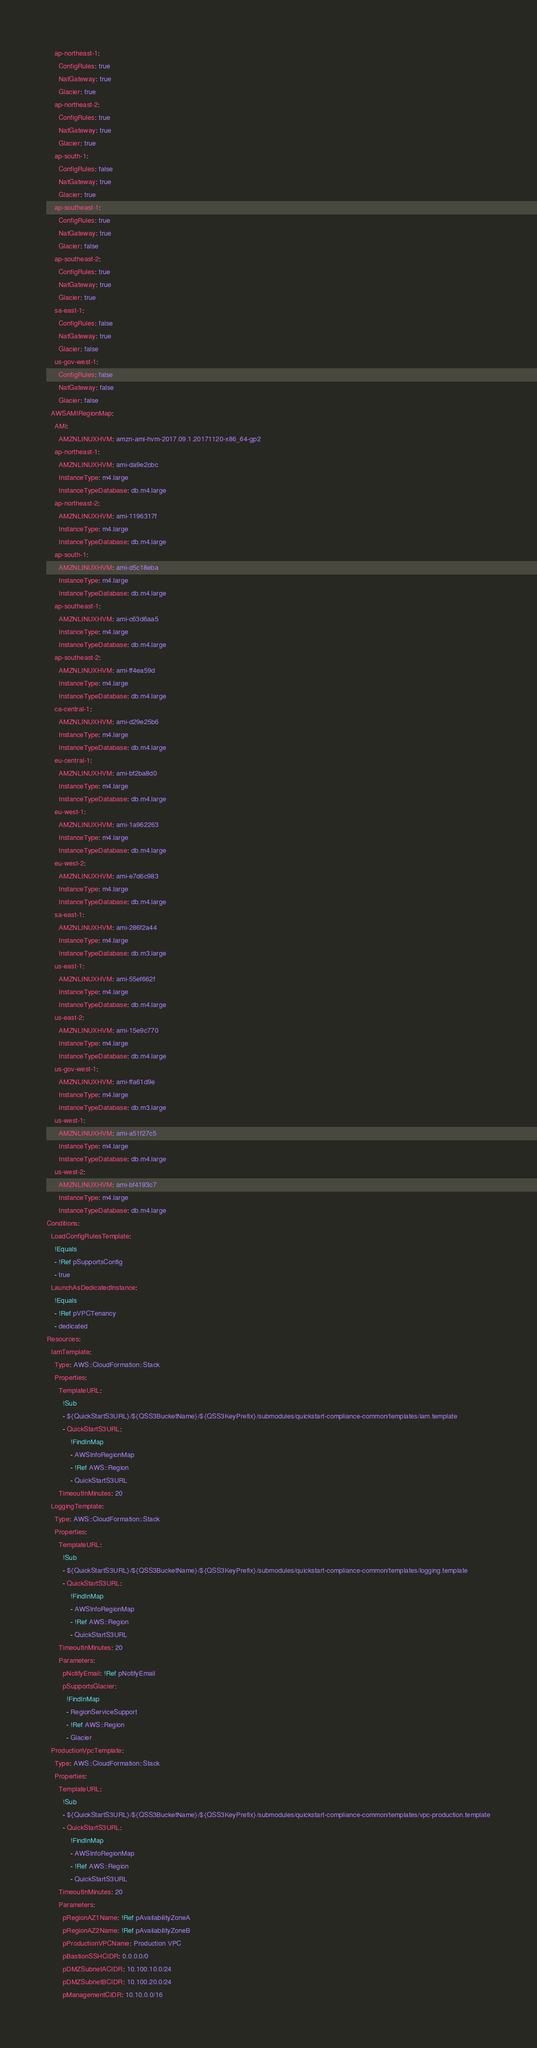Convert code to text. <code><loc_0><loc_0><loc_500><loc_500><_YAML_>    ap-northeast-1:
      ConfigRules: true
      NatGateway: true
      Glacier: true
    ap-northeast-2:
      ConfigRules: true
      NatGateway: true
      Glacier: true
    ap-south-1:
      ConfigRules: false
      NatGateway: true
      Glacier: true
    ap-southeast-1:
      ConfigRules: true
      NatGateway: true
      Glacier: false
    ap-southeast-2:
      ConfigRules: true
      NatGateway: true
      Glacier: true
    sa-east-1:
      ConfigRules: false
      NatGateway: true
      Glacier: false
    us-gov-west-1:
      ConfigRules: false
      NatGateway: false
      Glacier: false
  AWSAMIRegionMap:
    AMI:
      AMZNLINUXHVM: amzn-ami-hvm-2017.09.1.20171120-x86_64-gp2
    ap-northeast-1:
      AMZNLINUXHVM: ami-da9e2cbc
      InstanceType: m4.large
      InstanceTypeDatabase: db.m4.large
    ap-northeast-2:
      AMZNLINUXHVM: ami-1196317f
      InstanceType: m4.large
      InstanceTypeDatabase: db.m4.large
    ap-south-1:
      AMZNLINUXHVM: ami-d5c18eba
      InstanceType: m4.large
      InstanceTypeDatabase: db.m4.large
    ap-southeast-1:
      AMZNLINUXHVM: ami-c63d6aa5
      InstanceType: m4.large
      InstanceTypeDatabase: db.m4.large
    ap-southeast-2:
      AMZNLINUXHVM: ami-ff4ea59d
      InstanceType: m4.large
      InstanceTypeDatabase: db.m4.large
    ca-central-1:
      AMZNLINUXHVM: ami-d29e25b6
      InstanceType: m4.large
      InstanceTypeDatabase: db.m4.large
    eu-central-1:
      AMZNLINUXHVM: ami-bf2ba8d0
      InstanceType: m4.large
      InstanceTypeDatabase: db.m4.large
    eu-west-1:
      AMZNLINUXHVM: ami-1a962263
      InstanceType: m4.large
      InstanceTypeDatabase: db.m4.large
    eu-west-2:
      AMZNLINUXHVM: ami-e7d6c983
      InstanceType: m4.large
      InstanceTypeDatabase: db.m4.large
    sa-east-1:
      AMZNLINUXHVM: ami-286f2a44
      InstanceType: m4.large
      InstanceTypeDatabase: db.m3.large
    us-east-1:
      AMZNLINUXHVM: ami-55ef662f
      InstanceType: m4.large
      InstanceTypeDatabase: db.m4.large
    us-east-2:
      AMZNLINUXHVM: ami-15e9c770
      InstanceType: m4.large
      InstanceTypeDatabase: db.m4.large
    us-gov-west-1:
      AMZNLINUXHVM: ami-ffa61d9e
      InstanceType: m4.large
      InstanceTypeDatabase: db.m3.large
    us-west-1:
      AMZNLINUXHVM: ami-a51f27c5
      InstanceType: m4.large
      InstanceTypeDatabase: db.m4.large
    us-west-2:
      AMZNLINUXHVM: ami-bf4193c7
      InstanceType: m4.large
      InstanceTypeDatabase: db.m4.large
Conditions:
  LoadConfigRulesTemplate:
    !Equals
    - !Ref pSupportsConfig
    - true
  LaunchAsDedicatedInstance:
    !Equals
    - !Ref pVPCTenancy
    - dedicated
Resources:
  IamTemplate:
    Type: AWS::CloudFormation::Stack
    Properties:
      TemplateURL:
        !Sub
        - ${QuickStartS3URL}/${QSS3BucketName}/${QSS3KeyPrefix}/submodules/quickstart-compliance-common/templates/iam.template
        - QuickStartS3URL:
            !FindInMap
            - AWSInfoRegionMap
            - !Ref AWS::Region
            - QuickStartS3URL
      TimeoutInMinutes: 20
  LoggingTemplate:
    Type: AWS::CloudFormation::Stack
    Properties:
      TemplateURL:
        !Sub
        - ${QuickStartS3URL}/${QSS3BucketName}/${QSS3KeyPrefix}/submodules/quickstart-compliance-common/templates/logging.template
        - QuickStartS3URL:
            !FindInMap
            - AWSInfoRegionMap
            - !Ref AWS::Region
            - QuickStartS3URL
      TimeoutInMinutes: 20
      Parameters:
        pNotifyEmail: !Ref pNotifyEmail
        pSupportsGlacier:
          !FindInMap
          - RegionServiceSupport
          - !Ref AWS::Region
          - Glacier
  ProductionVpcTemplate:
    Type: AWS::CloudFormation::Stack
    Properties:
      TemplateURL:
        !Sub
        - ${QuickStartS3URL}/${QSS3BucketName}/${QSS3KeyPrefix}/submodules/quickstart-compliance-common/templates/vpc-production.template
        - QuickStartS3URL:
            !FindInMap
            - AWSInfoRegionMap
            - !Ref AWS::Region
            - QuickStartS3URL
      TimeoutInMinutes: 20
      Parameters:
        pRegionAZ1Name: !Ref pAvailabilityZoneA
        pRegionAZ2Name: !Ref pAvailabilityZoneB
        pProductionVPCName: Production VPC
        pBastionSSHCIDR: 0.0.0.0/0
        pDMZSubnetACIDR: 10.100.10.0/24
        pDMZSubnetBCIDR: 10.100.20.0/24
        pManagementCIDR: 10.10.0.0/16</code> 